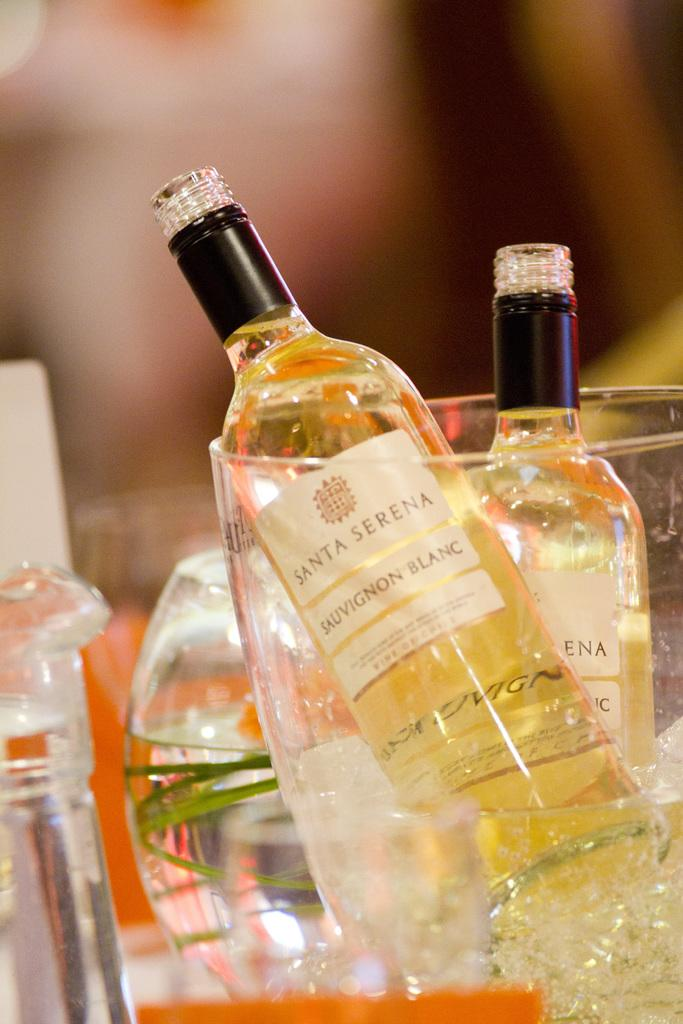Provide a one-sentence caption for the provided image. A bottle of Santa Serena sauvignon blanc sits in an ice bucket. 